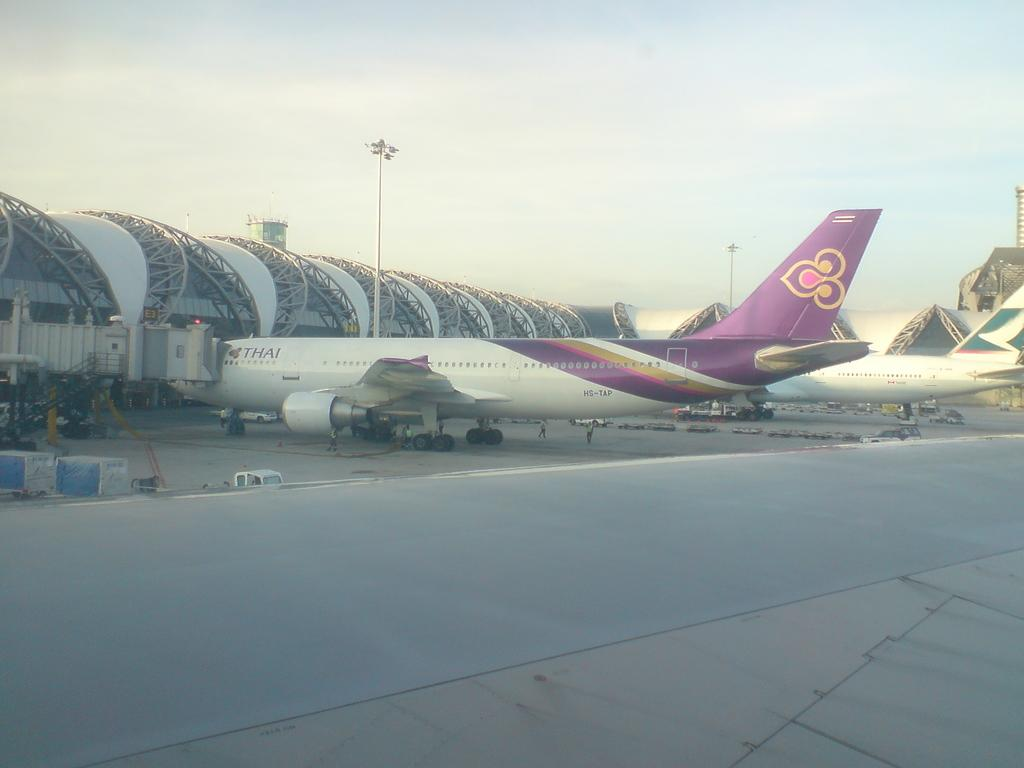What is the main subject of the image? The main subject of the image is airplanes on the ground. Can you describe the location of the airplanes? The airplanes are on the ground in the image. What can be seen in the background of the image? The sky is visible in the background of the image. What type of drum can be seen in the stomach of one of the airplanes in the image? There is no drum or any reference to a stomach in the image; it only features airplanes on the ground and the sky in the background. 